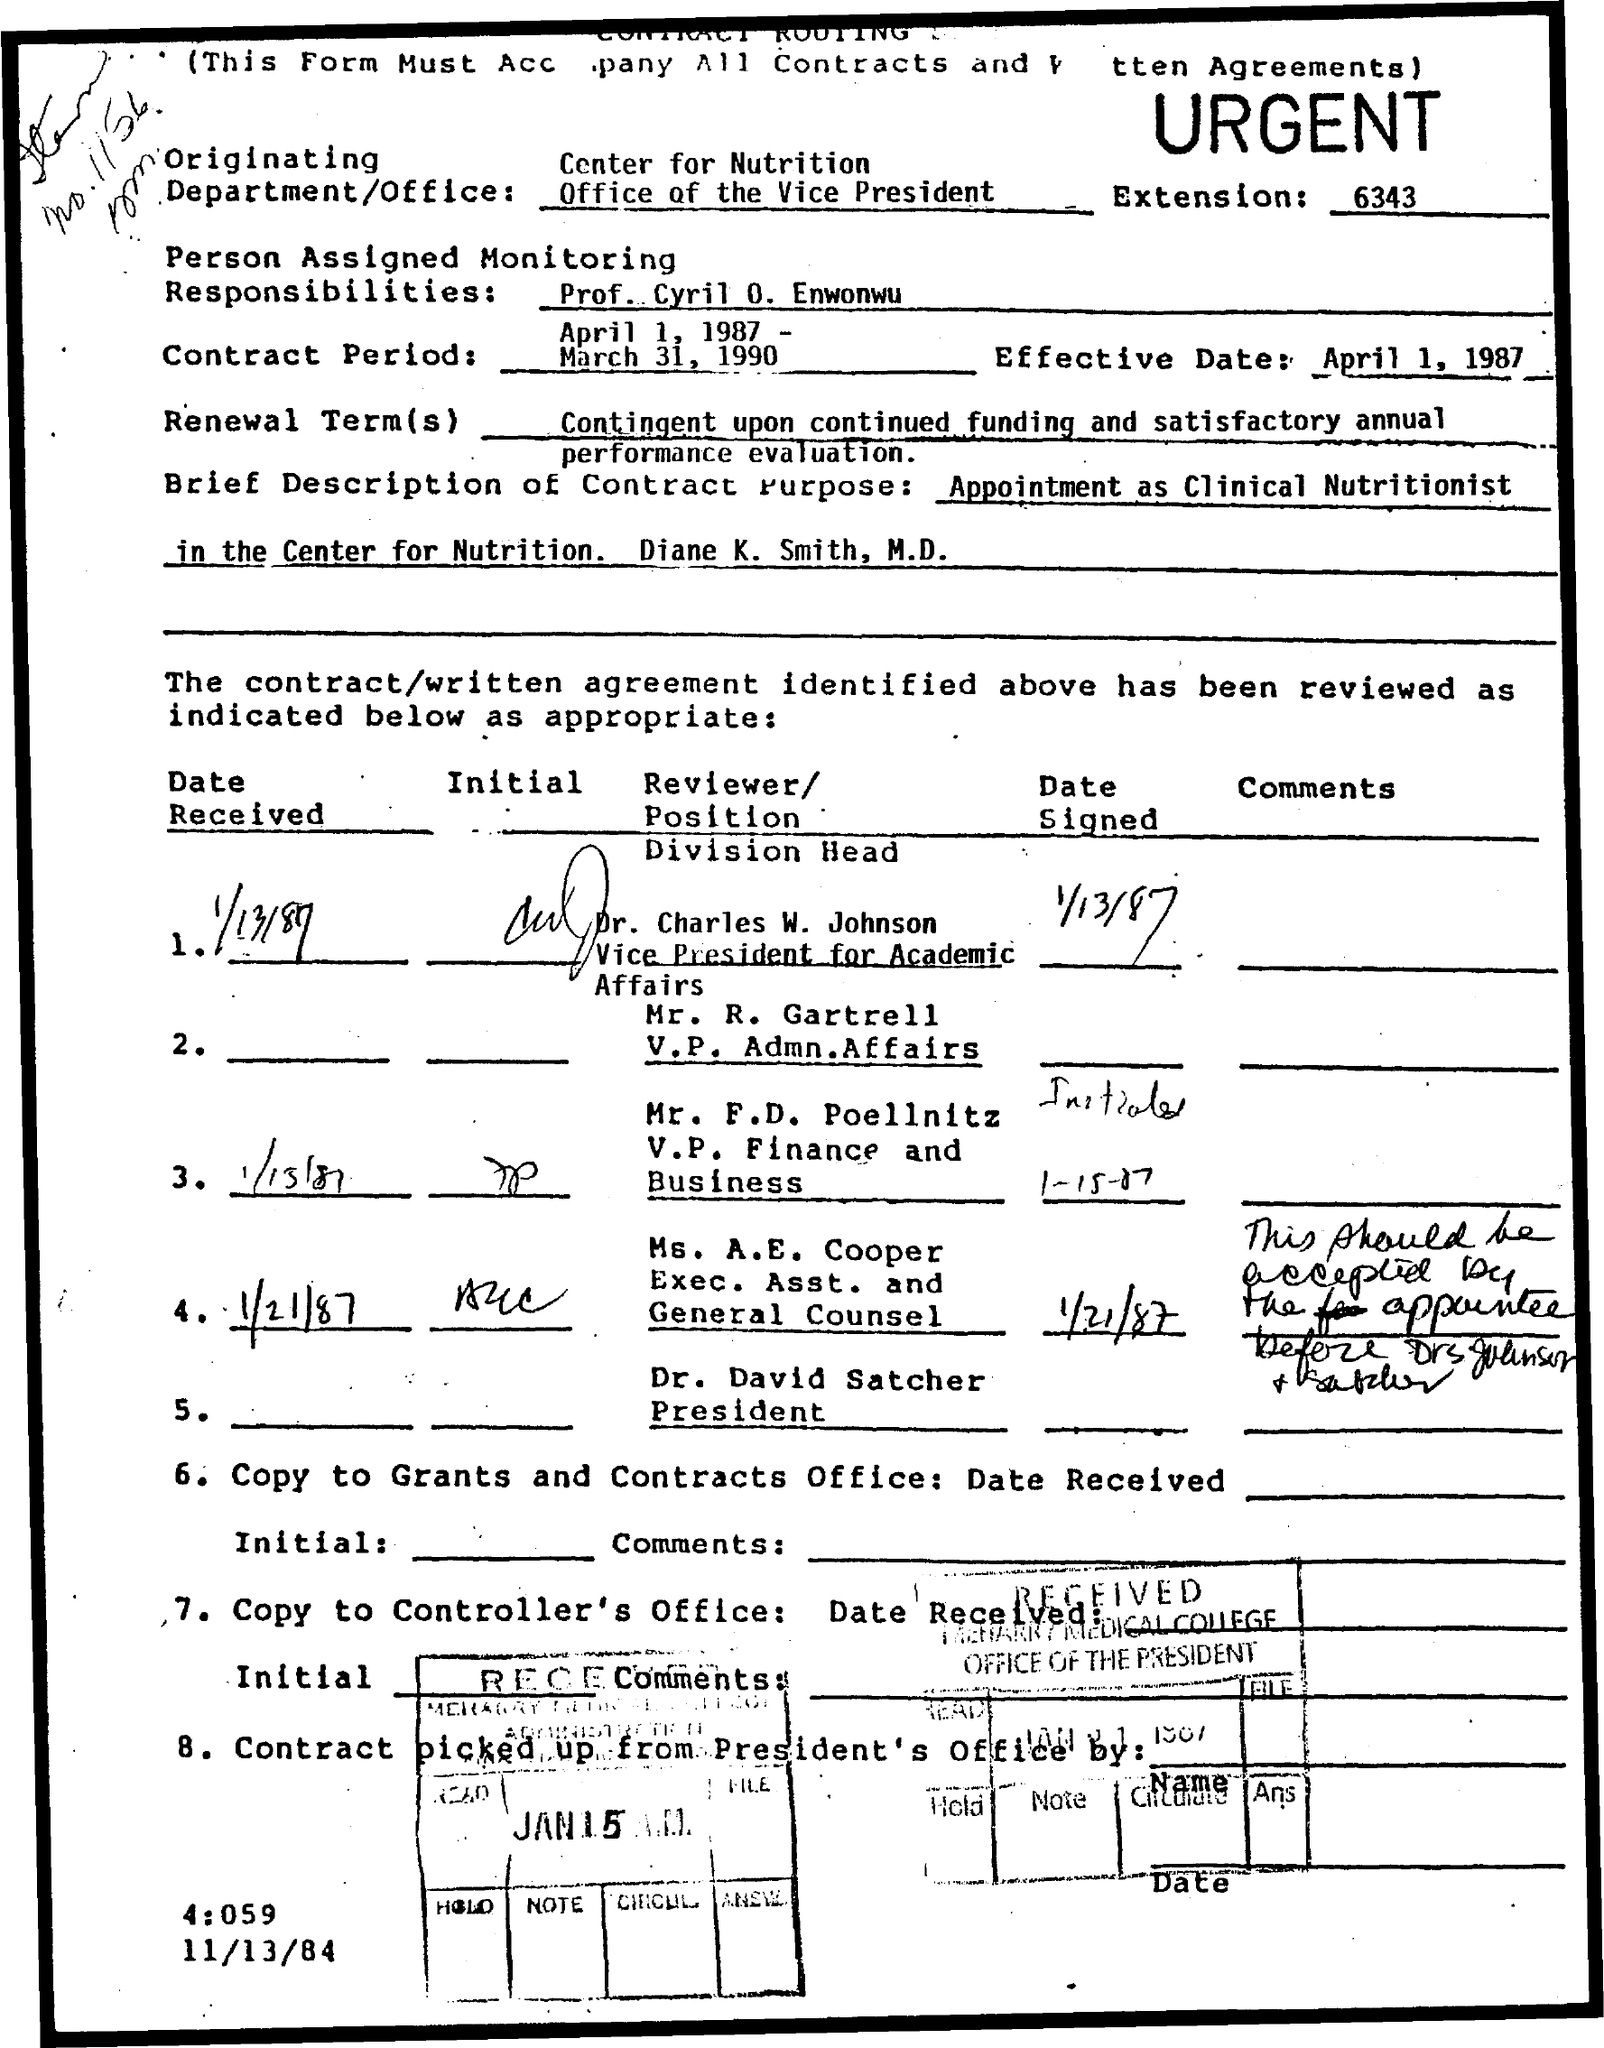What is the Extension?
Keep it short and to the point. 6343. Who is the person assigned monitoring responsibilities?
Your answer should be compact. Prof. Cyril O. Enwonwu. What is the Contract period?
Give a very brief answer. April 1, 1987 - March 31, 1990. What is the Effective Date?
Make the answer very short. April 1, 1987. 